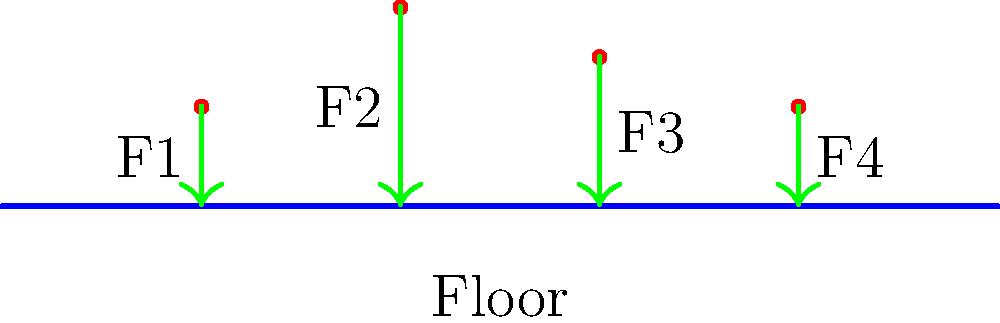During a group activity in your community center, four people are standing on the historic wooden floor as shown in the diagram. If the total weight of the four people is 2800 N and the floor area is 20 m², what is the average pressure exerted on the floor? Assume the weight is distributed unevenly as follows: F1 = 600 N, F2 = 800 N, F3 = 700 N, and F4 = 700 N. To solve this problem, we'll follow these steps:

1) First, let's confirm that the sum of individual forces equals the total weight:
   $600 \text{ N} + 800 \text{ N} + 700 \text{ N} + 700 \text{ N} = 2800 \text{ N}$

2) The pressure is defined as force per unit area:
   $P = \frac{F}{A}$

3) In this case, we're asked for the average pressure, so we'll use the total force (weight) and the total area:
   $P_{avg} = \frac{F_{total}}{A_{total}}$

4) We're given:
   $F_{total} = 2800 \text{ N}$
   $A_{total} = 20 \text{ m}^2$

5) Let's substitute these values into our pressure equation:
   $P_{avg} = \frac{2800 \text{ N}}{20 \text{ m}^2}$

6) Simplify:
   $P_{avg} = 140 \text{ N/m}^2$

Therefore, the average pressure exerted on the floor is 140 N/m² or 140 Pa.
Answer: 140 N/m² (or 140 Pa) 